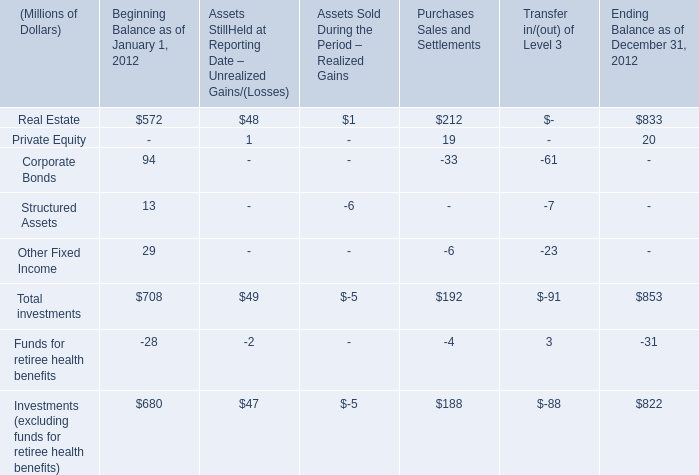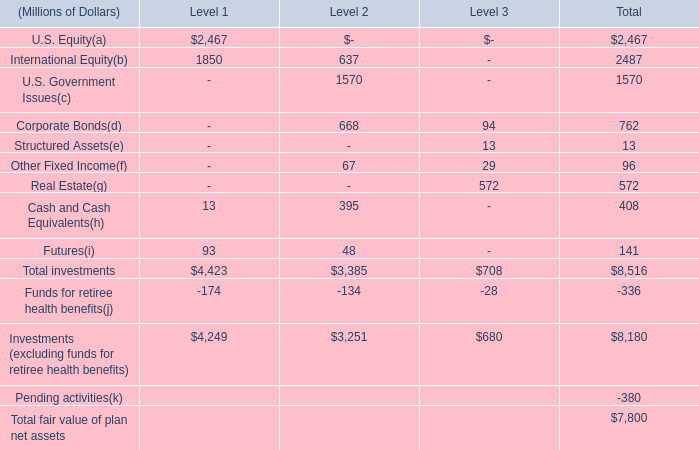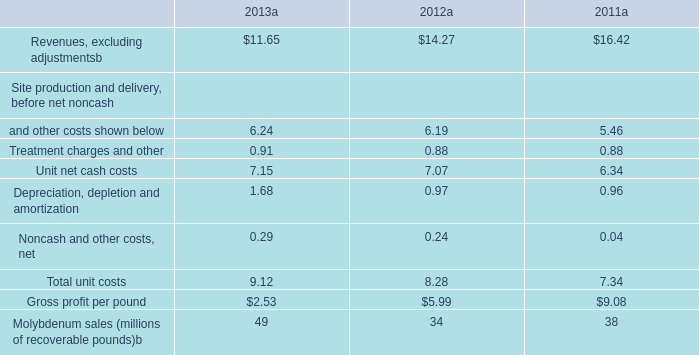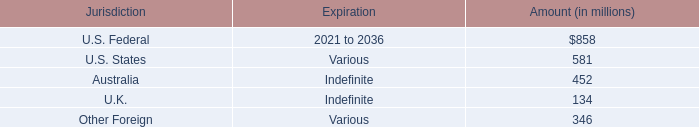What's the 10 % of total Real Estate in terms of Ending Balance as of December 31, 2012? (in Millions of Dollars) 
Computations: (0.1 * 833)
Answer: 83.3. 